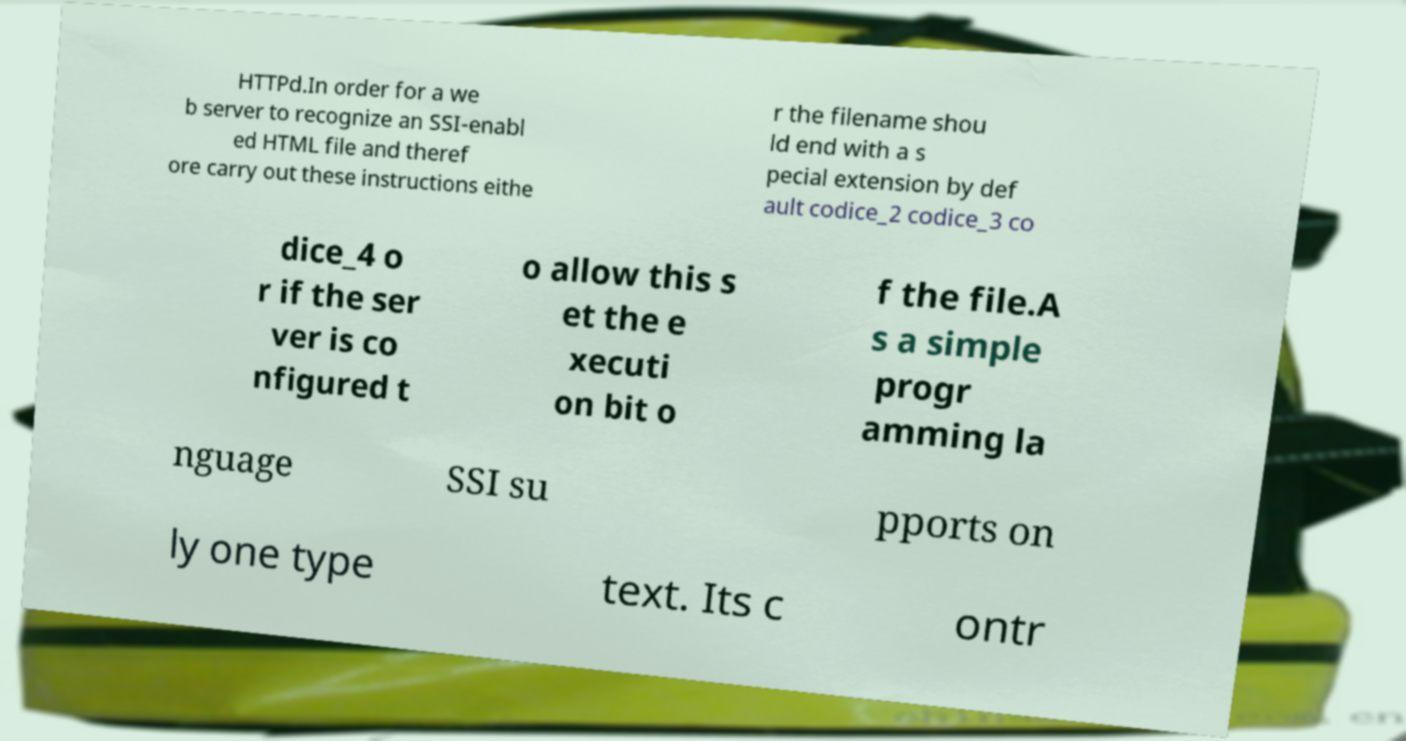For documentation purposes, I need the text within this image transcribed. Could you provide that? HTTPd.In order for a we b server to recognize an SSI-enabl ed HTML file and theref ore carry out these instructions eithe r the filename shou ld end with a s pecial extension by def ault codice_2 codice_3 co dice_4 o r if the ser ver is co nfigured t o allow this s et the e xecuti on bit o f the file.A s a simple progr amming la nguage SSI su pports on ly one type text. Its c ontr 